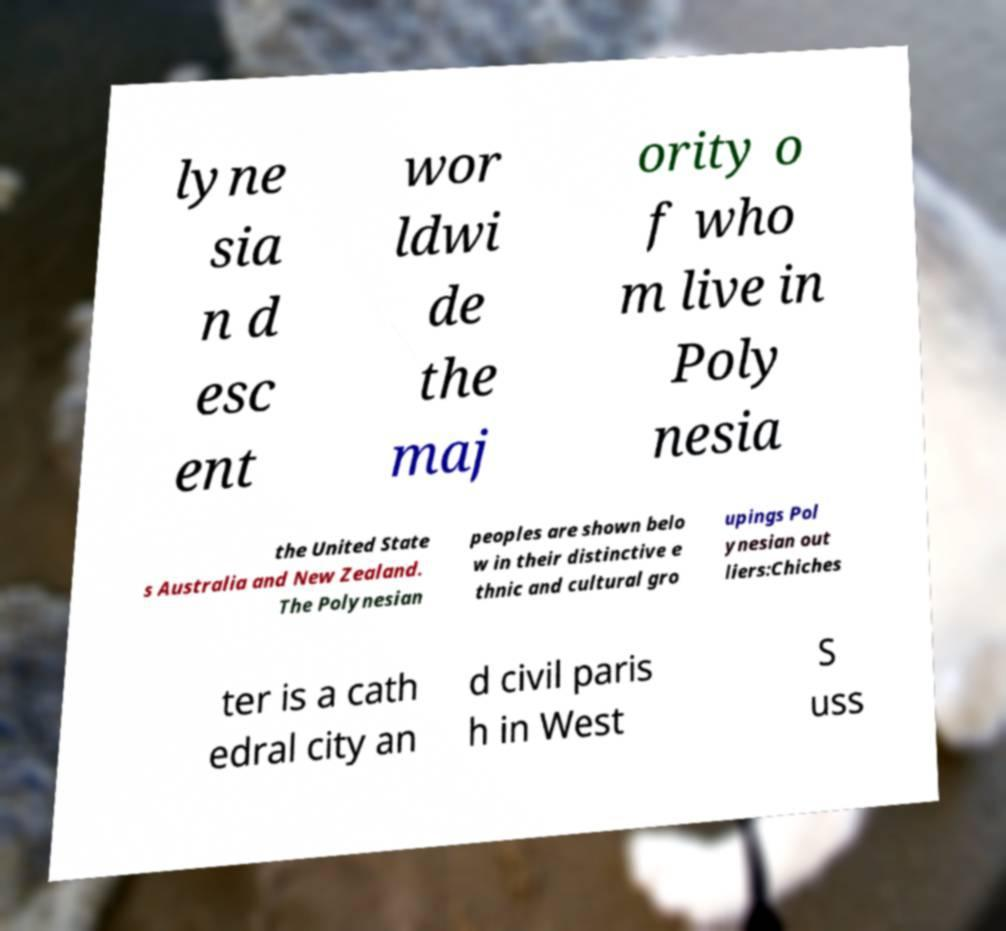Can you read and provide the text displayed in the image?This photo seems to have some interesting text. Can you extract and type it out for me? lyne sia n d esc ent wor ldwi de the maj ority o f who m live in Poly nesia the United State s Australia and New Zealand. The Polynesian peoples are shown belo w in their distinctive e thnic and cultural gro upings Pol ynesian out liers:Chiches ter is a cath edral city an d civil paris h in West S uss 